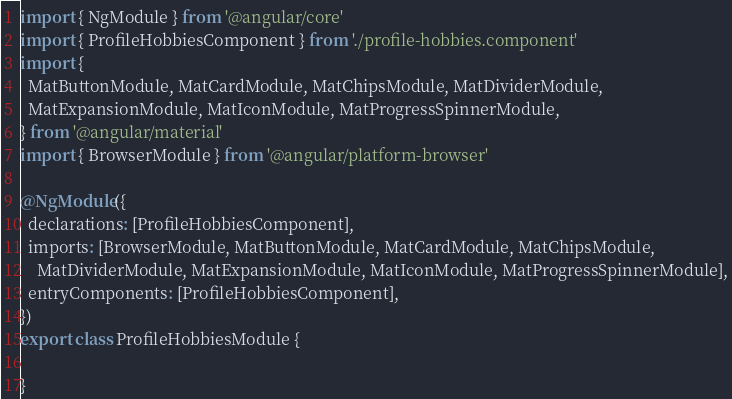Convert code to text. <code><loc_0><loc_0><loc_500><loc_500><_TypeScript_>import { NgModule } from '@angular/core'
import { ProfileHobbiesComponent } from './profile-hobbies.component'
import {
  MatButtonModule, MatCardModule, MatChipsModule, MatDividerModule,
  MatExpansionModule, MatIconModule, MatProgressSpinnerModule,
} from '@angular/material'
import { BrowserModule } from '@angular/platform-browser'

@NgModule({
  declarations: [ProfileHobbiesComponent],
  imports: [BrowserModule, MatButtonModule, MatCardModule, MatChipsModule,
    MatDividerModule, MatExpansionModule, MatIconModule, MatProgressSpinnerModule],
  entryComponents: [ProfileHobbiesComponent],
})
export class ProfileHobbiesModule {

}
</code> 